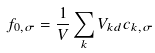<formula> <loc_0><loc_0><loc_500><loc_500>f _ { 0 , \sigma } = \frac { 1 } { V } \sum _ { k } V _ { k d } c _ { k , \sigma }</formula> 